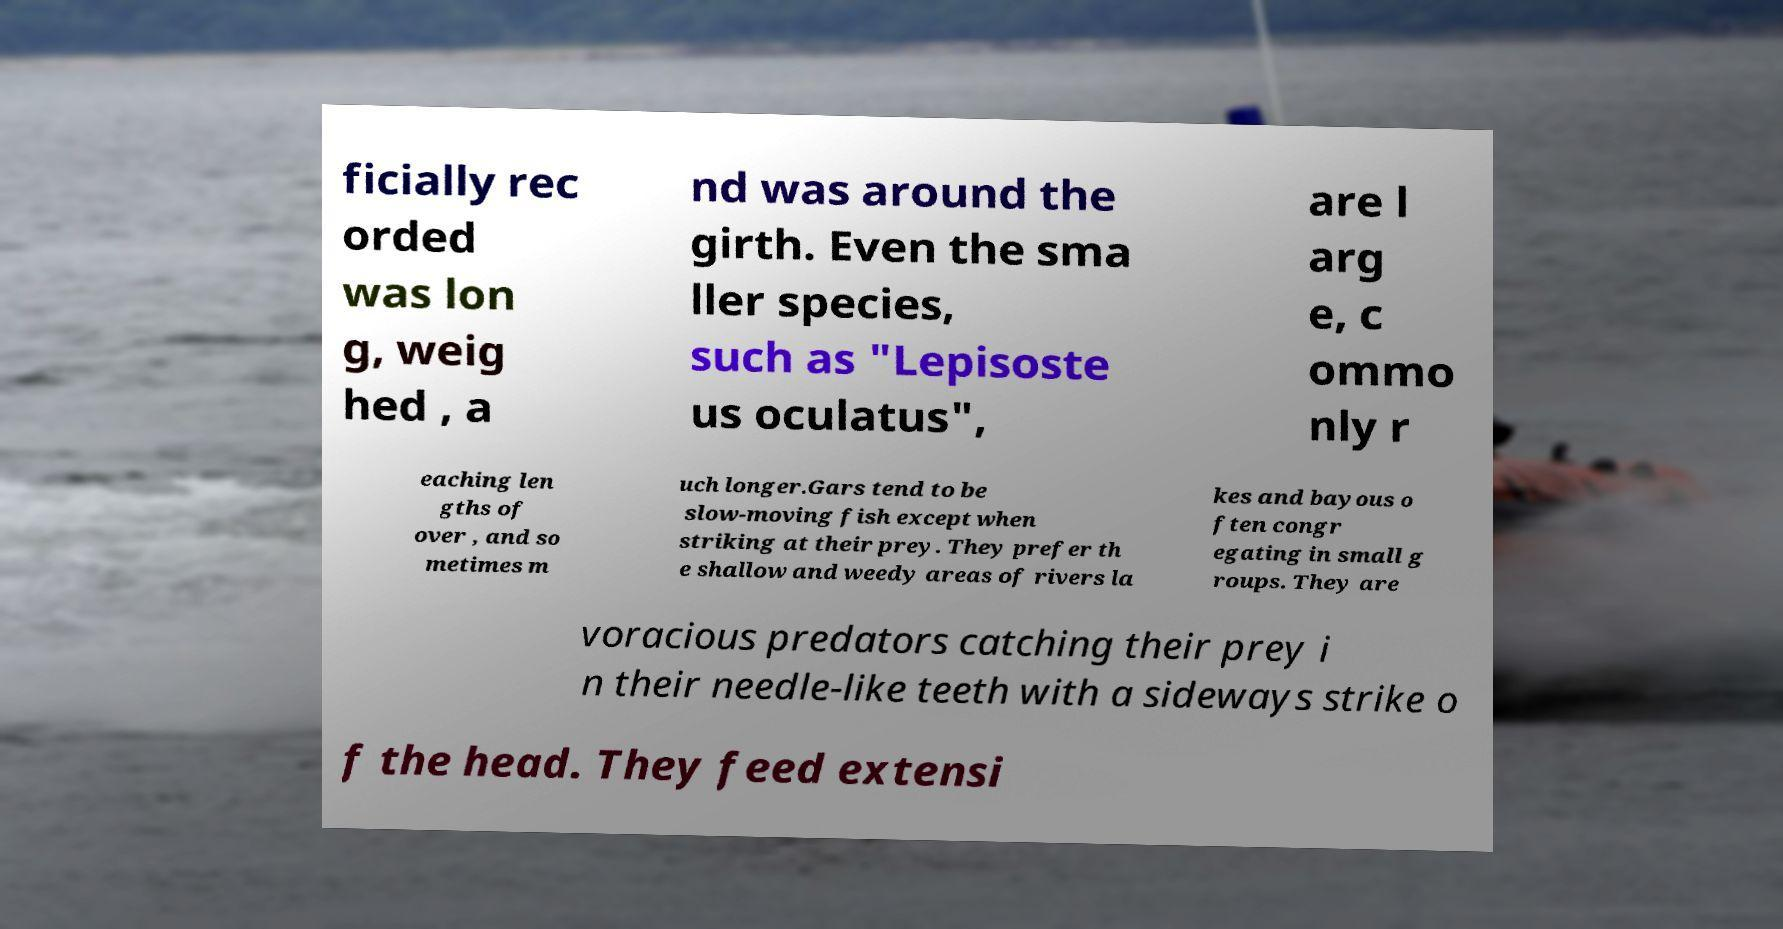What messages or text are displayed in this image? I need them in a readable, typed format. ficially rec orded was lon g, weig hed , a nd was around the girth. Even the sma ller species, such as "Lepisoste us oculatus", are l arg e, c ommo nly r eaching len gths of over , and so metimes m uch longer.Gars tend to be slow-moving fish except when striking at their prey. They prefer th e shallow and weedy areas of rivers la kes and bayous o ften congr egating in small g roups. They are voracious predators catching their prey i n their needle-like teeth with a sideways strike o f the head. They feed extensi 